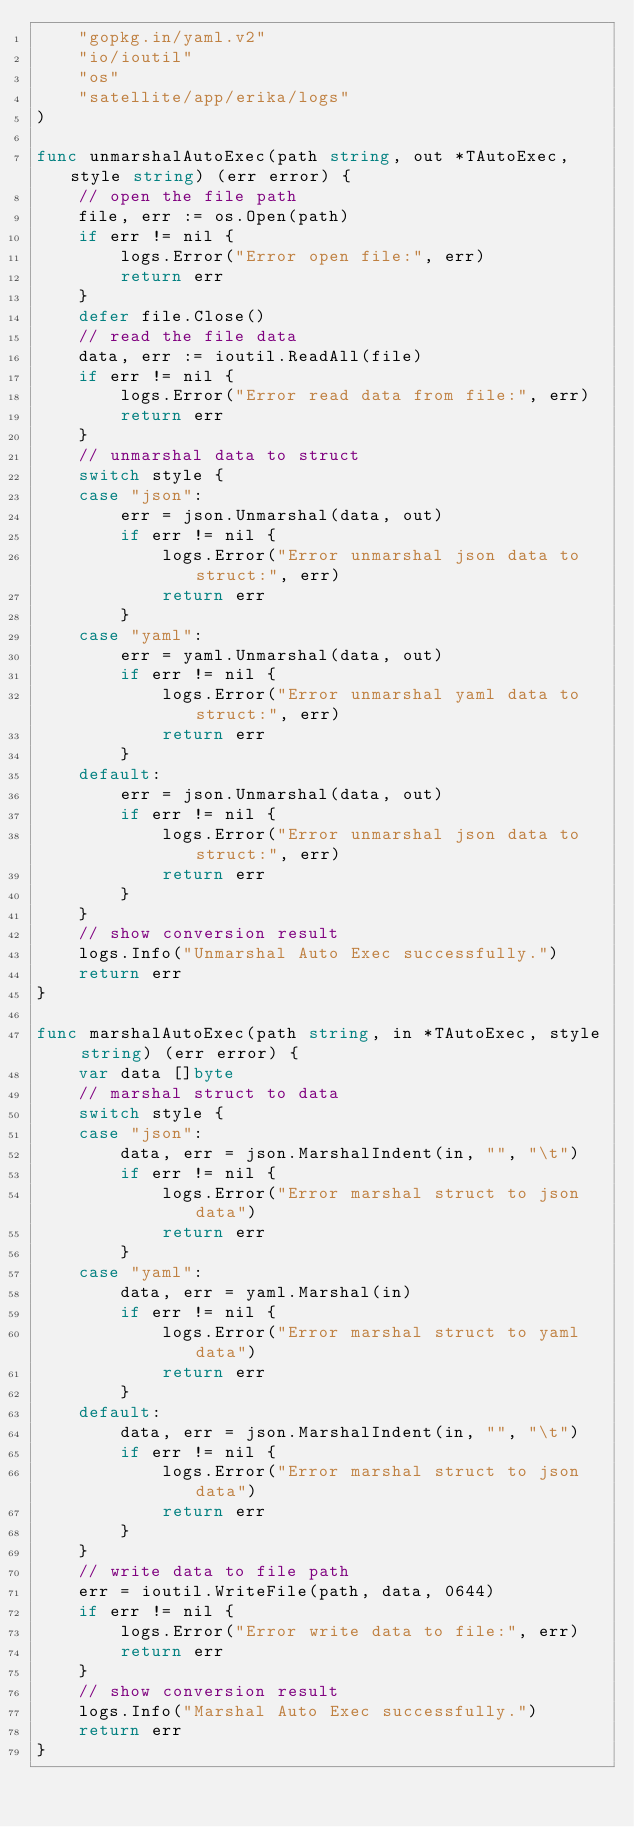Convert code to text. <code><loc_0><loc_0><loc_500><loc_500><_Go_>	"gopkg.in/yaml.v2"
	"io/ioutil"
	"os"
	"satellite/app/erika/logs"
)

func unmarshalAutoExec(path string, out *TAutoExec, style string) (err error) {
	// open the file path
	file, err := os.Open(path)
	if err != nil {
		logs.Error("Error open file:", err)
		return err
	}
	defer file.Close()
	// read the file data
	data, err := ioutil.ReadAll(file)
	if err != nil {
		logs.Error("Error read data from file:", err)
		return err
	}
	// unmarshal data to struct
	switch style {
	case "json":
		err = json.Unmarshal(data, out)
		if err != nil {
			logs.Error("Error unmarshal json data to struct:", err)
			return err
		}
	case "yaml":
		err = yaml.Unmarshal(data, out)
		if err != nil {
			logs.Error("Error unmarshal yaml data to struct:", err)
			return err
		}
	default:
		err = json.Unmarshal(data, out)
		if err != nil {
			logs.Error("Error unmarshal json data to struct:", err)
			return err
		}
	}
	// show conversion result
	logs.Info("Unmarshal Auto Exec successfully.")
	return err
}

func marshalAutoExec(path string, in *TAutoExec, style string) (err error) {
	var data []byte
	// marshal struct to data
	switch style {
	case "json":
		data, err = json.MarshalIndent(in, "", "\t")
		if err != nil {
			logs.Error("Error marshal struct to json data")
			return err
		}
	case "yaml":
		data, err = yaml.Marshal(in)
		if err != nil {
			logs.Error("Error marshal struct to yaml data")
			return err
		}
	default:
		data, err = json.MarshalIndent(in, "", "\t")
		if err != nil {
			logs.Error("Error marshal struct to json data")
			return err
		}
	}
	// write data to file path
	err = ioutil.WriteFile(path, data, 0644)
	if err != nil {
		logs.Error("Error write data to file:", err)
		return err
	}
	// show conversion result
	logs.Info("Marshal Auto Exec successfully.")
	return err
}
</code> 